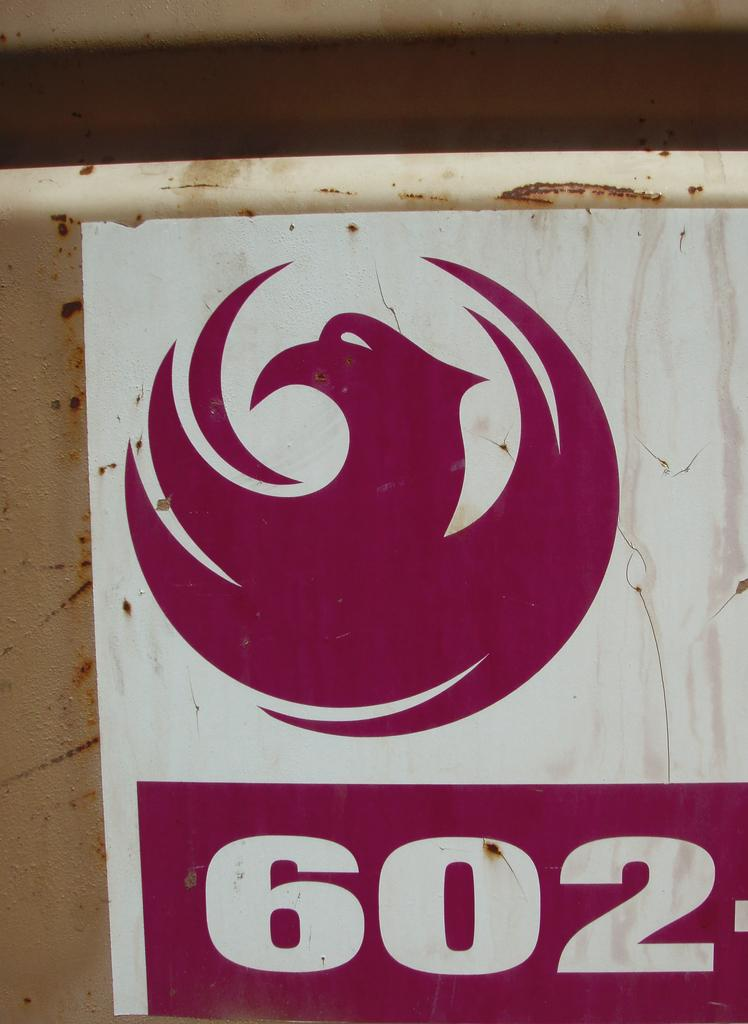<image>
Relay a brief, clear account of the picture shown. A red logo of a bird above the numbers 602. 